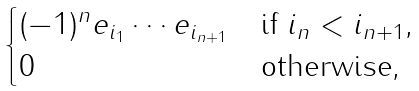Convert formula to latex. <formula><loc_0><loc_0><loc_500><loc_500>\begin{cases} ( - 1 ) ^ { n } e _ { i _ { 1 } } \cdots e _ { i _ { n + 1 } } & \text {if $i_{n}<i_{n+1}$,} \\ 0 & \text {otherwise,} \end{cases}</formula> 